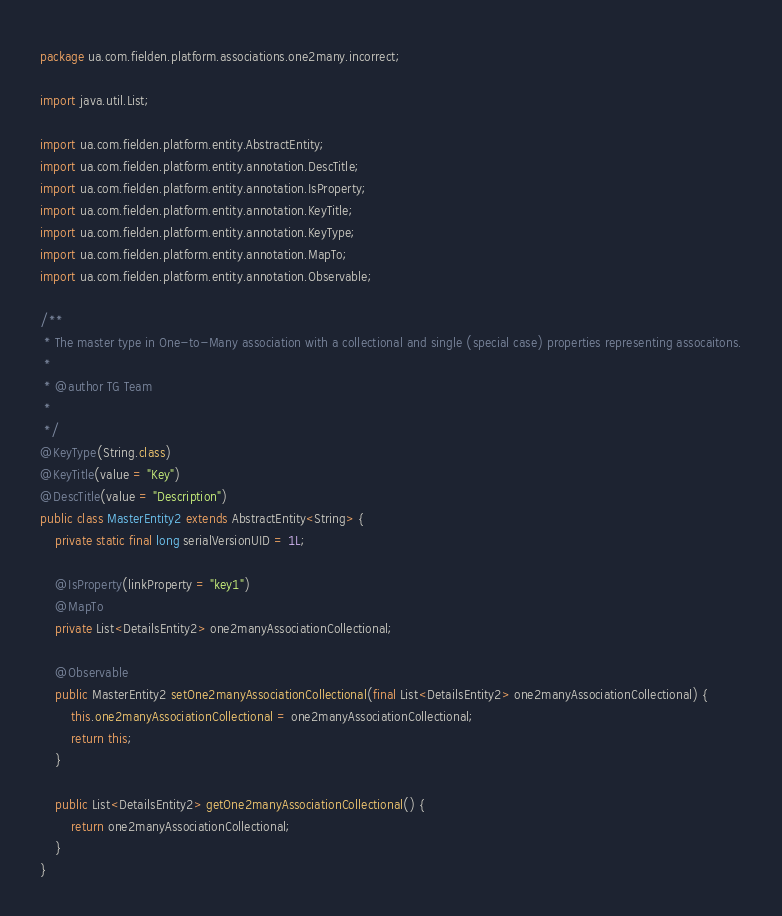Convert code to text. <code><loc_0><loc_0><loc_500><loc_500><_Java_>package ua.com.fielden.platform.associations.one2many.incorrect;

import java.util.List;

import ua.com.fielden.platform.entity.AbstractEntity;
import ua.com.fielden.platform.entity.annotation.DescTitle;
import ua.com.fielden.platform.entity.annotation.IsProperty;
import ua.com.fielden.platform.entity.annotation.KeyTitle;
import ua.com.fielden.platform.entity.annotation.KeyType;
import ua.com.fielden.platform.entity.annotation.MapTo;
import ua.com.fielden.platform.entity.annotation.Observable;

/**
 * The master type in One-to-Many association with a collectional and single (special case) properties representing assocaitons.
 * 
 * @author TG Team
 * 
 */
@KeyType(String.class)
@KeyTitle(value = "Key")
@DescTitle(value = "Description")
public class MasterEntity2 extends AbstractEntity<String> {
    private static final long serialVersionUID = 1L;

    @IsProperty(linkProperty = "key1")
    @MapTo
    private List<DetailsEntity2> one2manyAssociationCollectional;

    @Observable
    public MasterEntity2 setOne2manyAssociationCollectional(final List<DetailsEntity2> one2manyAssociationCollectional) {
        this.one2manyAssociationCollectional = one2manyAssociationCollectional;
        return this;
    }

    public List<DetailsEntity2> getOne2manyAssociationCollectional() {
        return one2manyAssociationCollectional;
    }
}
</code> 